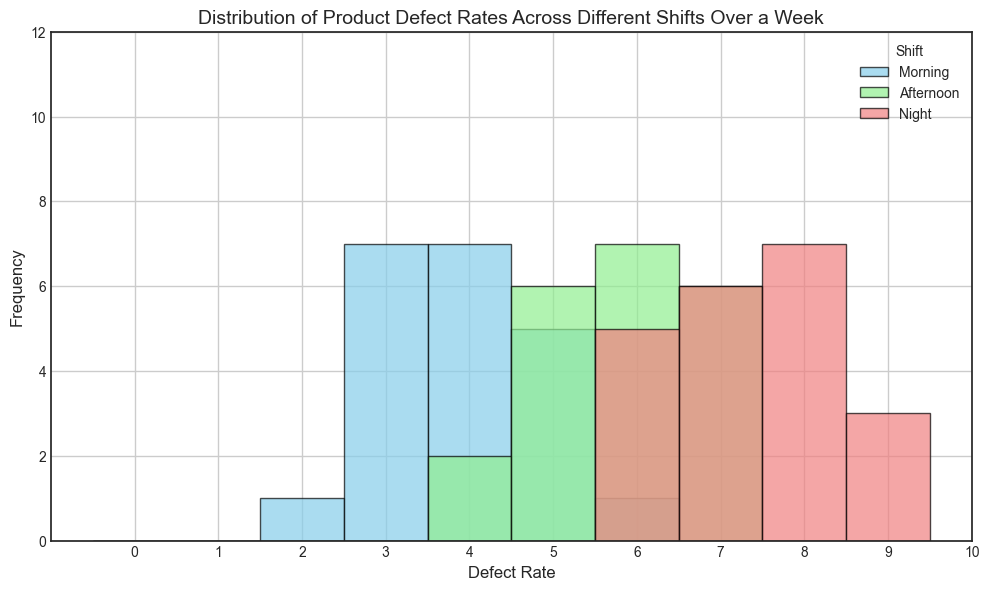What is the most common defect rate in the Night shift? Identify the tallest bar in the histogram for the Night shift (red color). The tallest bar corresponds to the defect rate occurring most frequently.
Answer: 7 Which shift has the highest frequency of defect rates clustered around 6? Look at the height of the bars at defect rate 6 across all shifts in the histogram. The shift with the tallest bar at defect rate 6 has the highest frequency.
Answer: Night How does the defect rate distribution in the Afternoon shift compare to the Morning shift? Compare the heights and spread of bars (in green for Afternoon and blue for Morning) across different defect rates to examine how they differ.
Answer: Afternoon shift tends toward higher defect rates than the Morning shift What is the combined frequency of defect rates 4 and 5 in the Morning shift? Sum the heights of the bars for defect rates 4 and 5 in the Morning shift (blue color) from the histogram.
Answer: 7 Which shift exhibits a defect rate of 8 more frequently? Find the bar corresponding to defect rate 8 in each shift and compare their heights. The shift with the tallest bar at 8 exhibits it more frequently.
Answer: Night What is the range of defect rates in the Morning shift? Identify the lowest and highest defect rates that appear in the Morning shift by looking at the spread of the bars in blue. The range is the difference between these two values.
Answer: 2 - 6 Is there a significant difference in defect rates between the Morning and Night shifts? Compare the overall spread and frequency distribution of defect rates (blue for Morning vs red for Night). Look at how defect rates vary and the height of distribution bars.
Answer: Yes, Night shift tends toward higher defect rates 